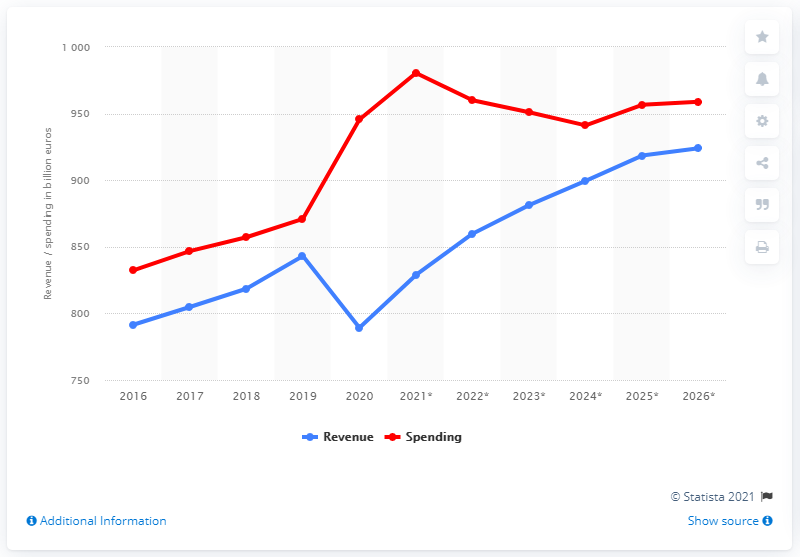Draw attention to some important aspects in this diagram. In 2020, Italy's government spending was 941.15 million. In 2020, the government revenue of Italy was 789.26 million. 